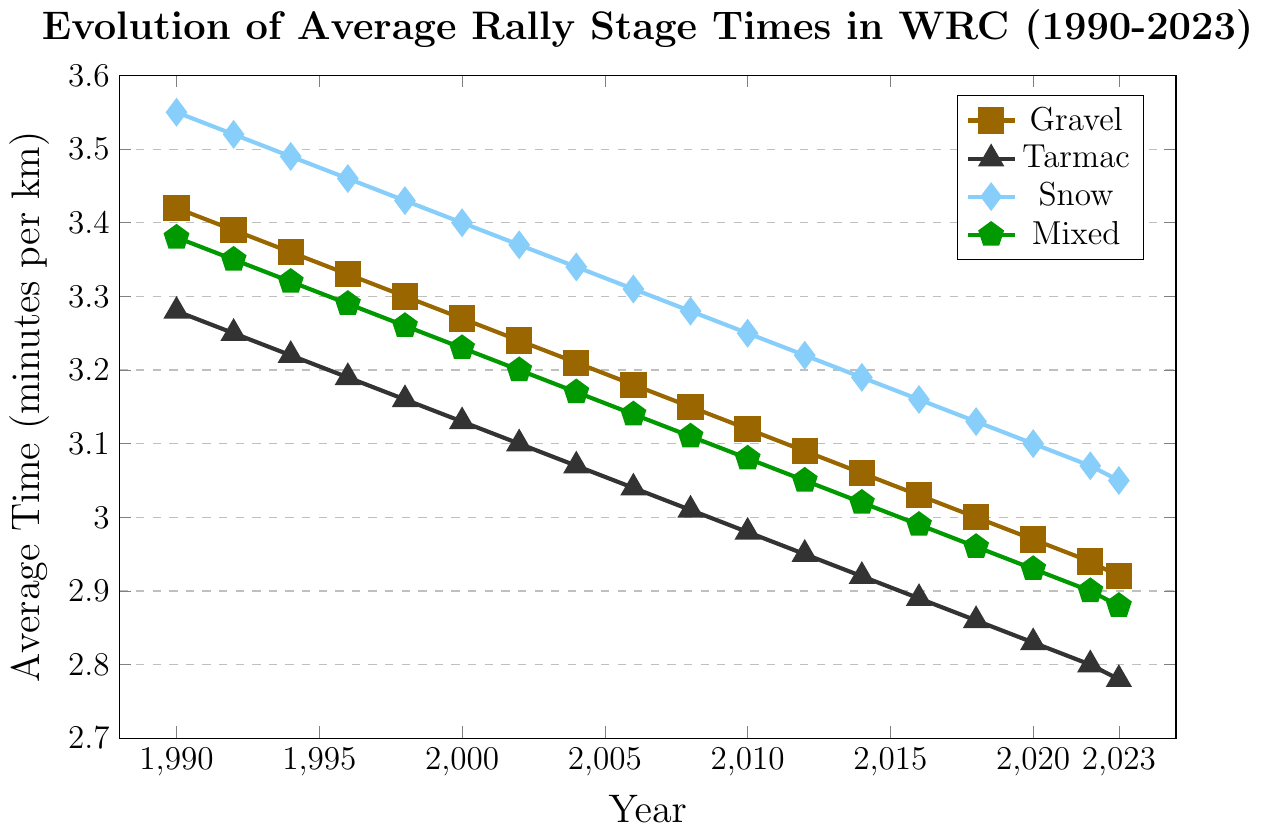What trend do you see in the average rally stage times on gravel surfaces from 1990 to 2023? The average rally stage times on gravel steadily decrease from 3.42 minutes per km in 1990 to 2.92 minutes per km in 2023. This shows a consistent improvement in stage times over the years.
Answer: Decreasing Which road surface type saw the largest decrease in average stage times between 1990 and 2023? To find this, we subtract the 2023 times from the 1990 times for each surface: Gravel (3.42 - 2.92 = 0.50), Tarmac (3.28 - 2.78 = 0.50), Snow (3.55 - 3.05 = 0.50), Mixed (3.38 - 2.88 = 0.50). All surface types saw the same decrease of 0.50 minutes per km.
Answer: All surfaces saw the same decrease (0.50 minutes) How do average stage times on snow surfaces in 1996 compare to those on mixed surfaces in 2023? The average stage time on snow in 1996 was 3.46 minutes per km, while on mixed surfaces in 2023 it was 2.88 minutes per km. Snow stages in 1996 were slower compared to mixed stages in 2023.
Answer: Snow in 1996 was 0.58 minutes slower Between 1990 and 2000, which road surface had the smallest improvement in average stage times? To determine the smallest improvement, we compare the differences over the decade: Gravel (3.42 - 3.27 = 0.15), Tarmac (3.28 - 3.13 = 0.15), Snow (3.55 - 3.40 = 0.15), Mixed (3.38 - 3.23 = 0.15). All surfaces had the smallest improvement of 0.15 minutes per km.
Answer: All surfaces had the smallest improvement (0.15 minutes) What was the approximate overall decrease in average rally stage times on tarmac from 1990 to 2010? By subtracting the 2010 value from the 1990 value for tarmac, we get (3.28 - 2.98 = 0.30).
Answer: 0.30 minutes Which year shows the closest average stage times across all road surface types? The year with the smallest range between the highest and lowest values will be closest. In 2023, the range is from Snow (3.05) to Tarmac (2.78), a difference of 0.27 minutes, which is the smallest range across the years presented.
Answer: 2023 Does the average stage time for mixed surfaces in 1994 fall above or below the average stage time for snow surfaces in 2020? The average stage time for mixed surfaces in 1994 was 3.32 minutes, while for snow surfaces in 2020 it was 3.10 minutes. Thus, the average time for mixed 1994 is above snow 2020.
Answer: Above Calculate the average pace decline per year for gravel surfaces from 1990 to 2023. To find the average decline per year, subtract the 2023 time from the 1990 time and divide by the number of years: (3.42 - 2.92) / (2023 - 1990) = 0.50 / 33 ≈ 0.0152 minutes per year.
Answer: 0.0152 minutes per year 